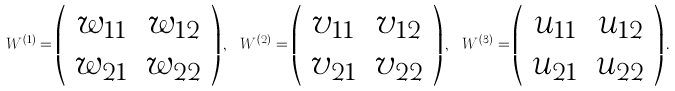Convert formula to latex. <formula><loc_0><loc_0><loc_500><loc_500>W ^ { ( 1 ) } = \left ( \begin{array} { c c } w _ { 1 1 } & w _ { 1 2 } \\ w _ { 2 1 } & w _ { 2 2 } \end{array} \right ) , \ W ^ { ( 2 ) } = \left ( \begin{array} { c c } v _ { 1 1 } & v _ { 1 2 } \\ v _ { 2 1 } & v _ { 2 2 } \end{array} \right ) , \ W ^ { ( 3 ) } = \left ( \begin{array} { c c } u _ { 1 1 } & u _ { 1 2 } \\ u _ { 2 1 } & u _ { 2 2 } \end{array} \right ) .</formula> 